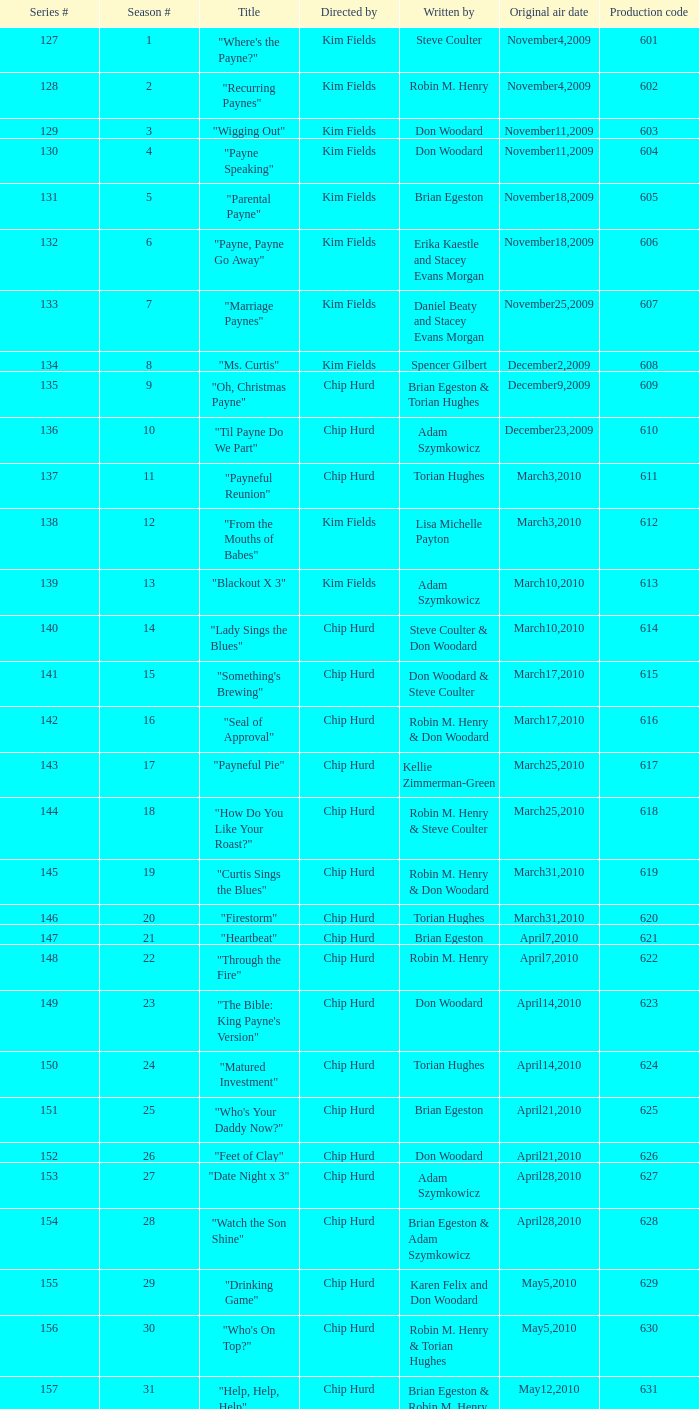For the title "firestorm," when did the original air dates occur? March31,2010. 